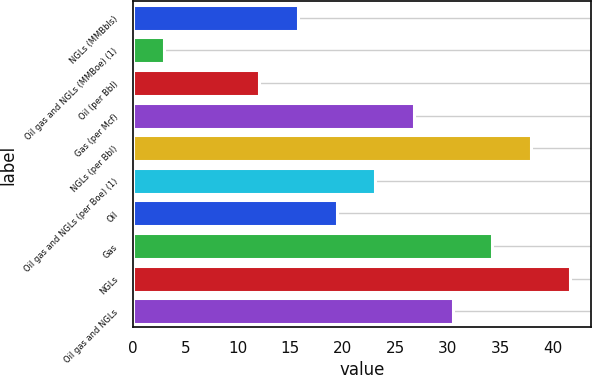Convert chart. <chart><loc_0><loc_0><loc_500><loc_500><bar_chart><fcel>NGLs (MMBbls)<fcel>Oil gas and NGLs (MMBoe) (1)<fcel>Oil (per Bbl)<fcel>Gas (per Mcf)<fcel>NGLs (per Bbl)<fcel>Oil gas and NGLs (per Boe) (1)<fcel>Oil<fcel>Gas<fcel>NGLs<fcel>Oil gas and NGLs<nl><fcel>15.7<fcel>3<fcel>12<fcel>26.8<fcel>37.9<fcel>23.1<fcel>19.4<fcel>34.2<fcel>41.6<fcel>30.5<nl></chart> 